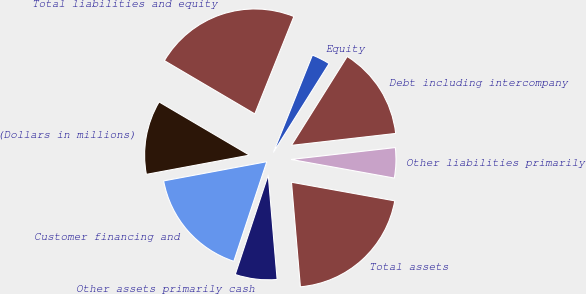<chart> <loc_0><loc_0><loc_500><loc_500><pie_chart><fcel>(Dollars in millions)<fcel>Customer financing and<fcel>Other assets primarily cash<fcel>Total assets<fcel>Other liabilities primarily<fcel>Debt including intercompany<fcel>Equity<fcel>Total liabilities and equity<nl><fcel>11.4%<fcel>16.98%<fcel>6.44%<fcel>20.81%<fcel>4.65%<fcel>14.27%<fcel>2.85%<fcel>22.6%<nl></chart> 